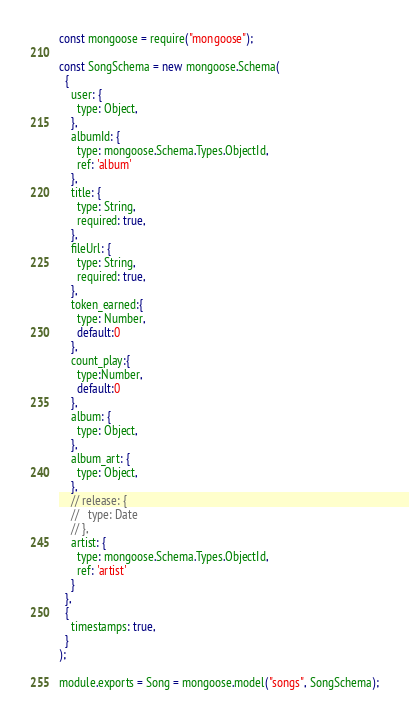Convert code to text. <code><loc_0><loc_0><loc_500><loc_500><_JavaScript_>const mongoose = require("mongoose");

const SongSchema = new mongoose.Schema(
  {
    user: {
      type: Object,
    },
    albumId: {
      type: mongoose.Schema.Types.ObjectId,
      ref: 'album'
    },
    title: {
      type: String,
      required: true,
    },
    fileUrl: {
      type: String,
      required: true,
    },
    token_earned:{
      type: Number,
      default:0
    },
    count_play:{
      type:Number,
      default:0
    },
    album: {
      type: Object,
    },
    album_art: {
      type: Object,
    },
    // release: {
    //   type: Date
    // },
    artist: {
      type: mongoose.Schema.Types.ObjectId,
      ref: 'artist'
    }
  },
  {
    timestamps: true,
  }
);

module.exports = Song = mongoose.model("songs", SongSchema);
</code> 